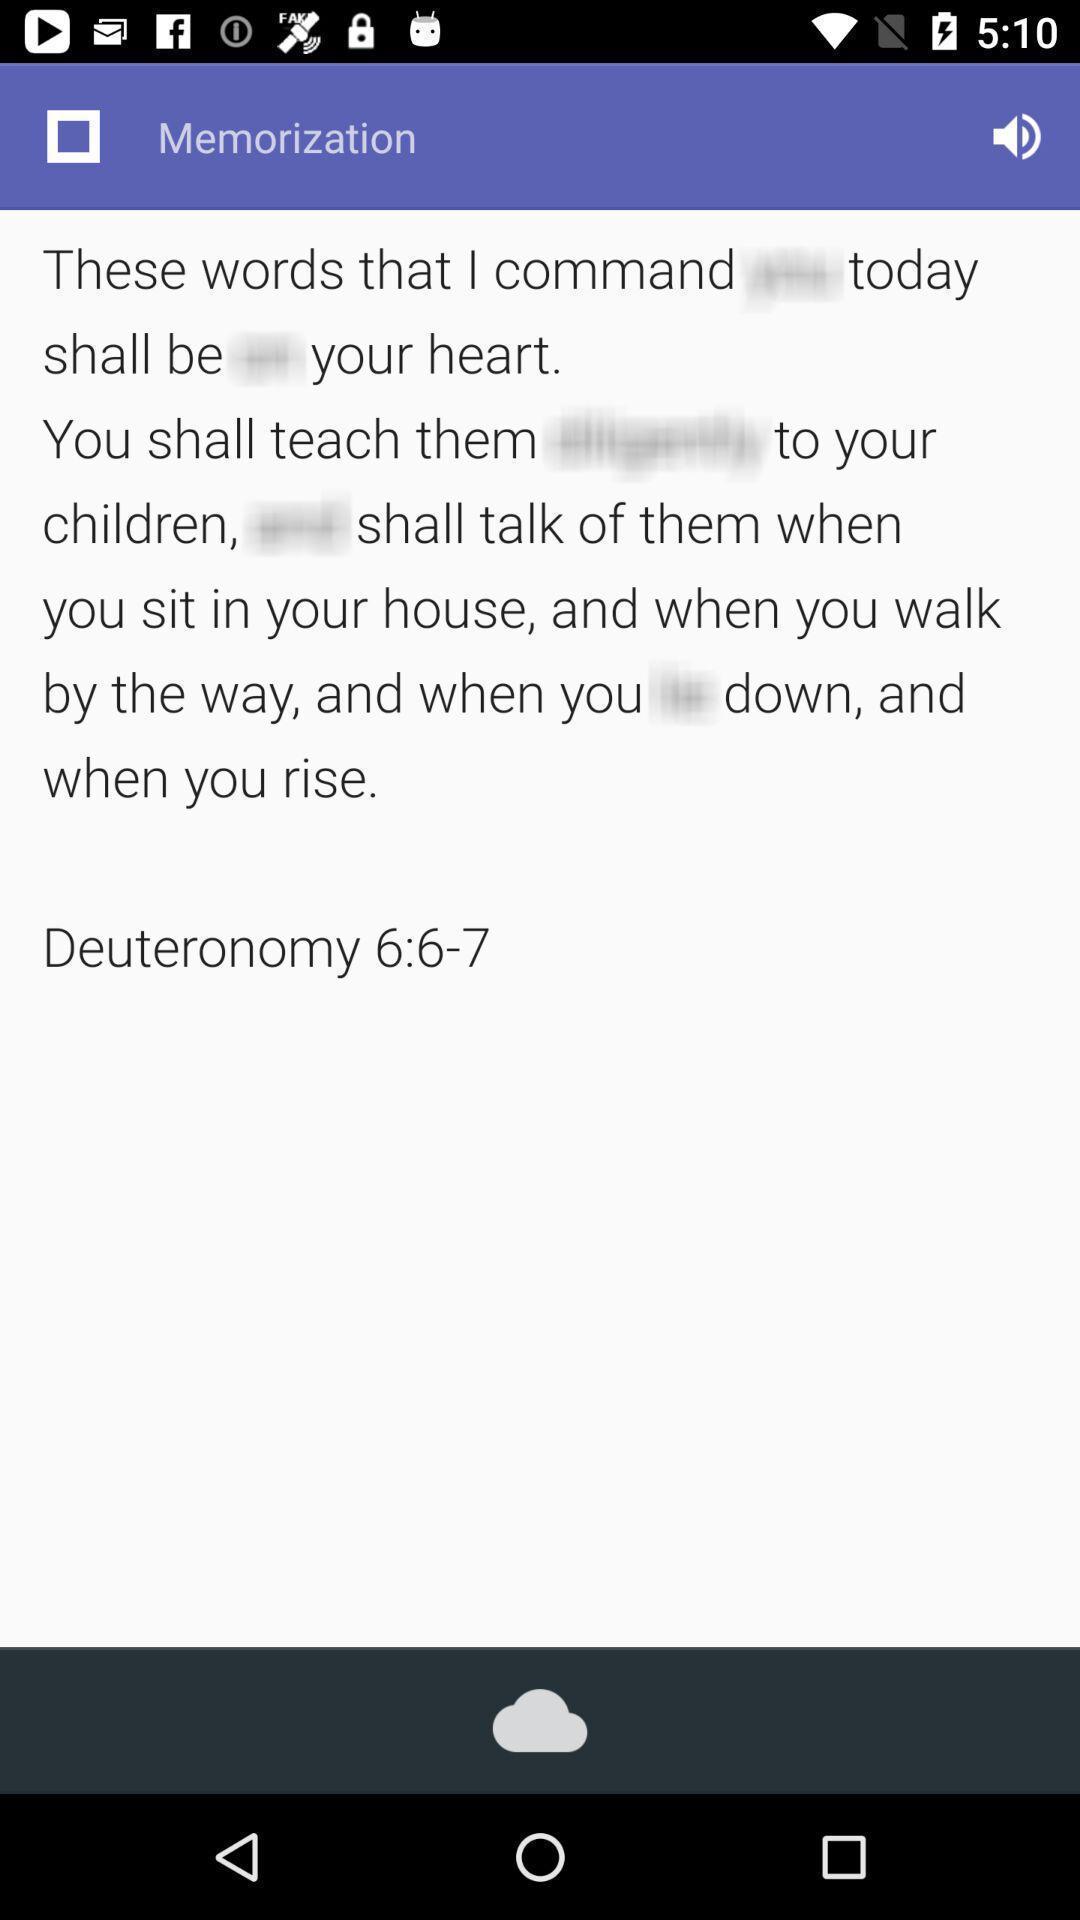Describe the content in this image. Screen showing memorization. 